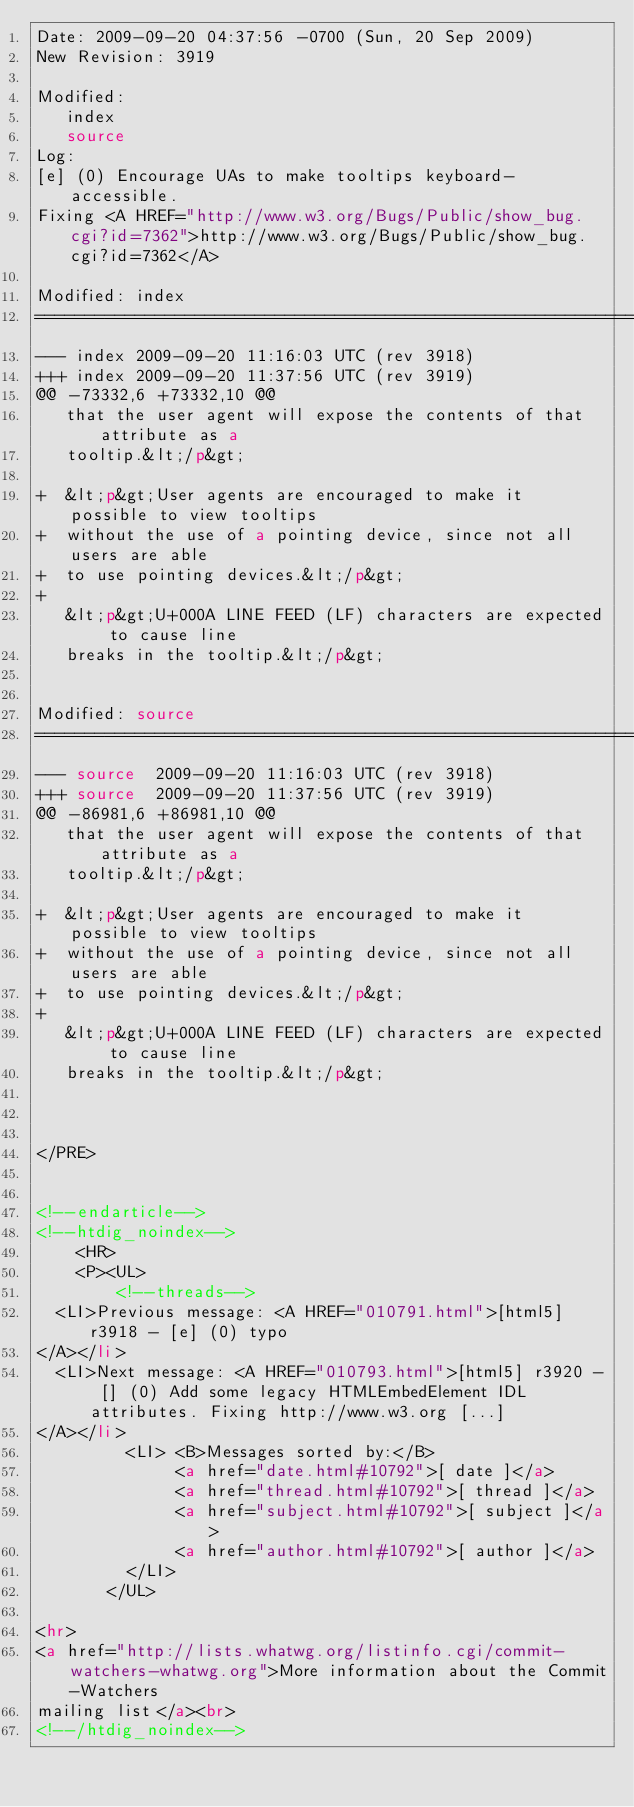Convert code to text. <code><loc_0><loc_0><loc_500><loc_500><_HTML_>Date: 2009-09-20 04:37:56 -0700 (Sun, 20 Sep 2009)
New Revision: 3919

Modified:
   index
   source
Log:
[e] (0) Encourage UAs to make tooltips keyboard-accessible.
Fixing <A HREF="http://www.w3.org/Bugs/Public/show_bug.cgi?id=7362">http://www.w3.org/Bugs/Public/show_bug.cgi?id=7362</A>

Modified: index
===================================================================
--- index	2009-09-20 11:16:03 UTC (rev 3918)
+++ index	2009-09-20 11:37:56 UTC (rev 3919)
@@ -73332,6 +73332,10 @@
   that the user agent will expose the contents of that attribute as a
   tooltip.&lt;/p&gt;
 
+  &lt;p&gt;User agents are encouraged to make it possible to view tooltips
+  without the use of a pointing device, since not all users are able
+  to use pointing devices.&lt;/p&gt;
+
   &lt;p&gt;U+000A LINE FEED (LF) characters are expected to cause line
   breaks in the tooltip.&lt;/p&gt;
 

Modified: source
===================================================================
--- source	2009-09-20 11:16:03 UTC (rev 3918)
+++ source	2009-09-20 11:37:56 UTC (rev 3919)
@@ -86981,6 +86981,10 @@
   that the user agent will expose the contents of that attribute as a
   tooltip.&lt;/p&gt;
 
+  &lt;p&gt;User agents are encouraged to make it possible to view tooltips
+  without the use of a pointing device, since not all users are able
+  to use pointing devices.&lt;/p&gt;
+
   &lt;p&gt;U+000A LINE FEED (LF) characters are expected to cause line
   breaks in the tooltip.&lt;/p&gt;
 


</PRE>


<!--endarticle-->
<!--htdig_noindex-->
    <HR>
    <P><UL>
        <!--threads-->
	<LI>Previous message: <A HREF="010791.html">[html5] r3918 - [e] (0) typo
</A></li>
	<LI>Next message: <A HREF="010793.html">[html5] r3920 - [] (0) Add some legacy HTMLEmbedElement IDL	attributes. Fixing http://www.w3.org [...]
</A></li>
         <LI> <B>Messages sorted by:</B> 
              <a href="date.html#10792">[ date ]</a>
              <a href="thread.html#10792">[ thread ]</a>
              <a href="subject.html#10792">[ subject ]</a>
              <a href="author.html#10792">[ author ]</a>
         </LI>
       </UL>

<hr>
<a href="http://lists.whatwg.org/listinfo.cgi/commit-watchers-whatwg.org">More information about the Commit-Watchers
mailing list</a><br>
<!--/htdig_noindex--></code> 